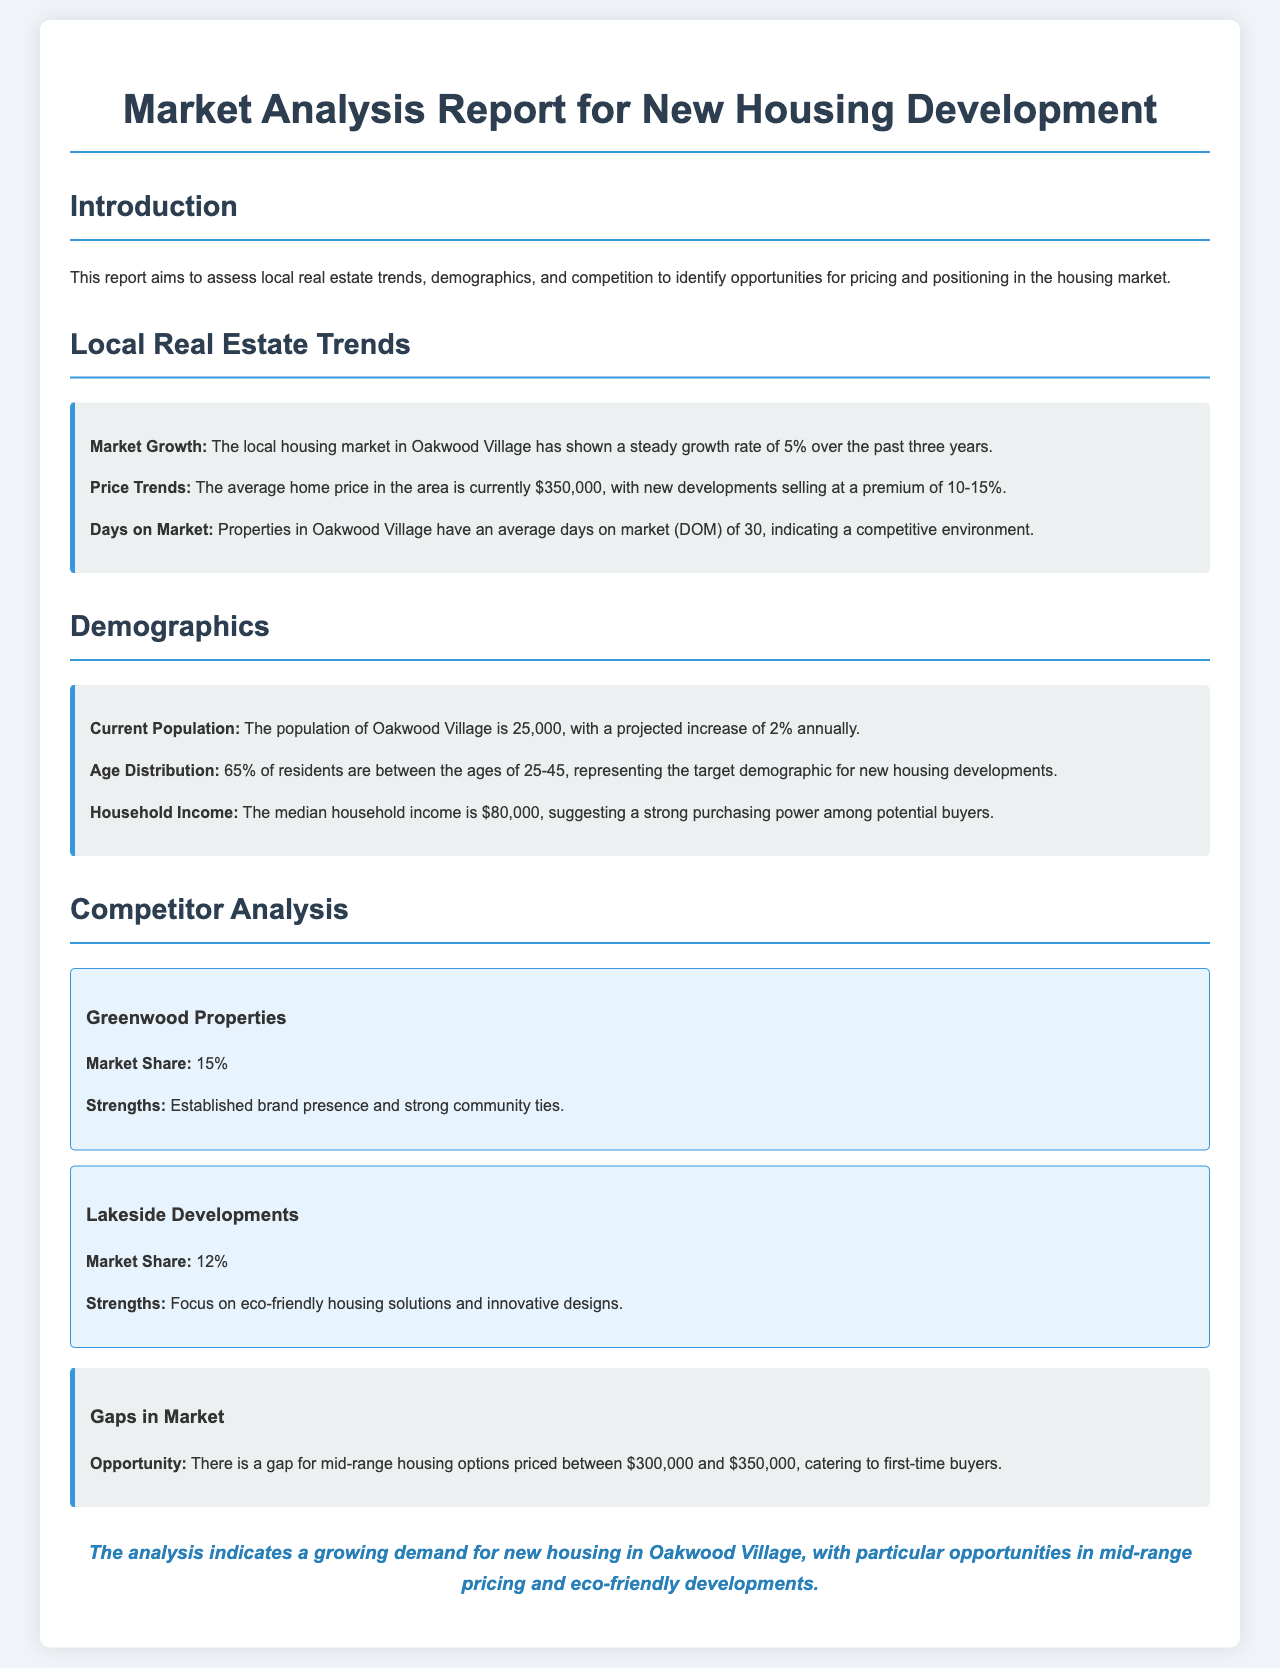What is the current population of Oakwood Village? The current population is explicitly stated in the demographic section of the report.
Answer: 25,000 What is the average home price in the area? The average home price is mentioned under local real estate trends.
Answer: $350,000 What percentage of residents are between the ages of 25-45? This demographic detail is detailed in the demographics section of the report.
Answer: 65% What is the market growth rate for the housing market in Oakwood Village? The growth rate is provided in the local real estate trends section.
Answer: 5% What gap in the market is identified for new housing? The opportunity for mid-range housing is specified in the competitor analysis.
Answer: Mid-range housing options priced between $300,000 and $350,000 What is the median household income in Oakwood Village? The information about household income can be found in the demographics section.
Answer: $80,000 Which company has a market share of 15%? This information is found in the competitor analysis section.
Answer: Greenwood Properties What is the average days on the market for properties in Oakwood Village? The statistic is provided in the local real estate trends section.
Answer: 30 What does the conclusion of the report indicate? The conclusion summarizes the demand for new housing and potential opportunities.
Answer: Growing demand for new housing in Oakwood Village 